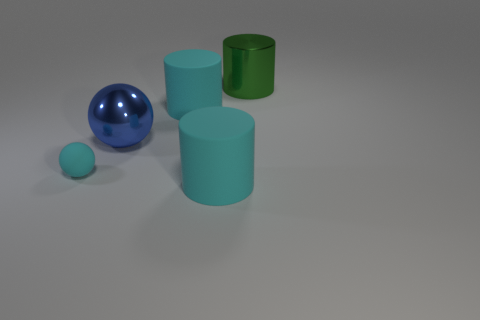Add 4 big cyan rubber things. How many objects exist? 9 Subtract all spheres. How many objects are left? 3 Add 4 tiny cyan matte balls. How many tiny cyan matte balls exist? 5 Subtract 0 green spheres. How many objects are left? 5 Subtract all spheres. Subtract all large green metallic blocks. How many objects are left? 3 Add 5 small cyan things. How many small cyan things are left? 6 